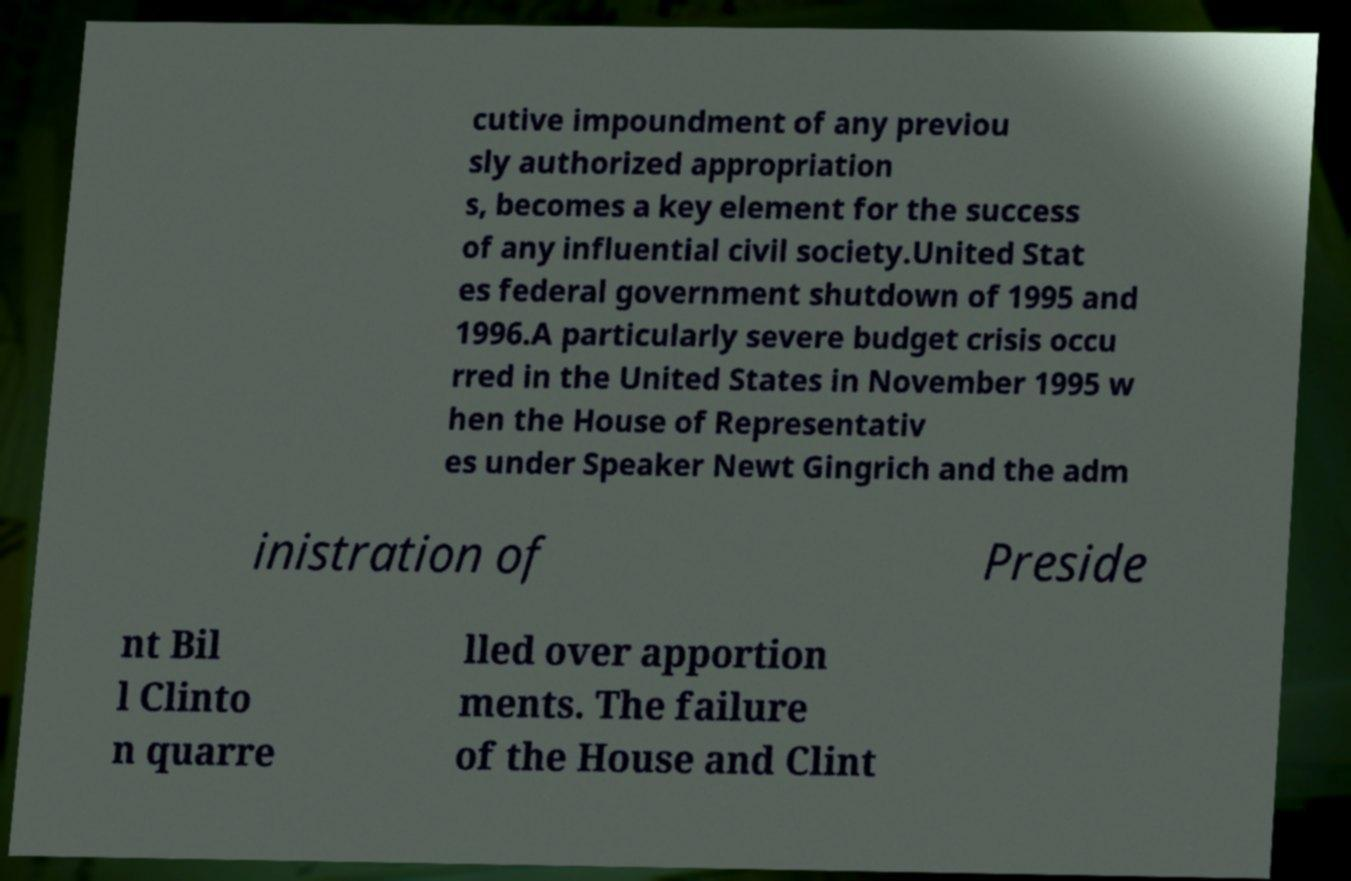Can you read and provide the text displayed in the image?This photo seems to have some interesting text. Can you extract and type it out for me? cutive impoundment of any previou sly authorized appropriation s, becomes a key element for the success of any influential civil society.United Stat es federal government shutdown of 1995 and 1996.A particularly severe budget crisis occu rred in the United States in November 1995 w hen the House of Representativ es under Speaker Newt Gingrich and the adm inistration of Preside nt Bil l Clinto n quarre lled over apportion ments. The failure of the House and Clint 